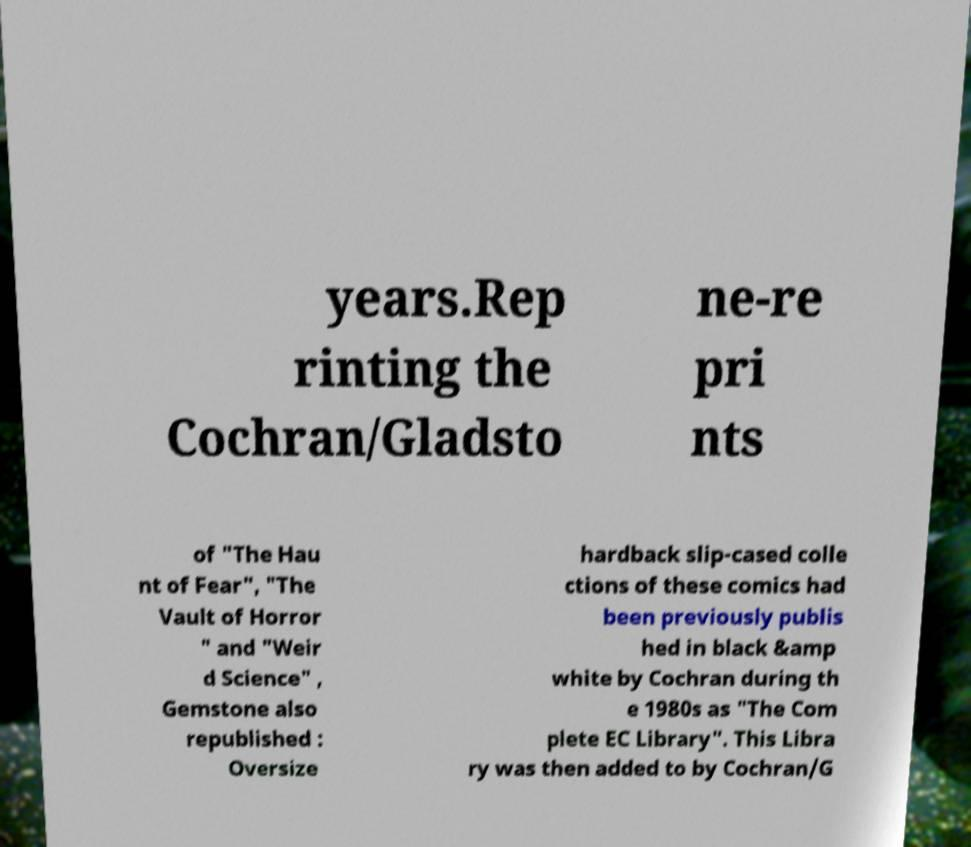Can you accurately transcribe the text from the provided image for me? years.Rep rinting the Cochran/Gladsto ne-re pri nts of "The Hau nt of Fear", "The Vault of Horror " and "Weir d Science" , Gemstone also republished : Oversize hardback slip-cased colle ctions of these comics had been previously publis hed in black &amp white by Cochran during th e 1980s as "The Com plete EC Library". This Libra ry was then added to by Cochran/G 